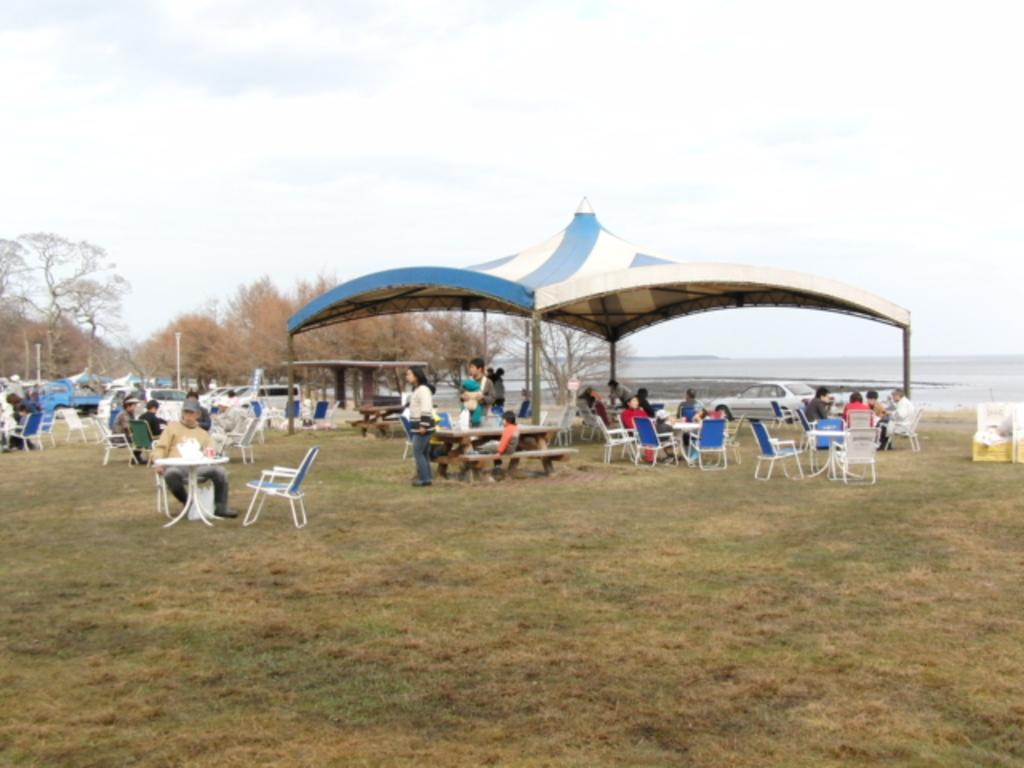How many people are in the image? There is a group of people in the image, but the exact number is not specified. What are the people in the image doing? Some people are seated, while others are standing. What type of furniture is present in the image? There are chairs and tables in the image. What type of shelter is visible in the image? There is a tent in the image. What type of natural elements can be seen in the image? There are trees in the image. What type of transportation is visible in the image? There are vehicles in the image. What type of foot is visible on the tray in the image? There is no tray or foot present in the image. What type of apparel is being worn by the people in the image? The provided facts do not mention the apparel worn by the people in the image. 